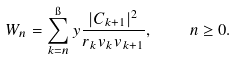Convert formula to latex. <formula><loc_0><loc_0><loc_500><loc_500>W _ { n } = \sum _ { k = n } ^ { \i } y \frac { | C _ { k + 1 } | ^ { 2 } } { r _ { k } v _ { k } v _ { k + 1 } } , \quad n \geq 0 .</formula> 